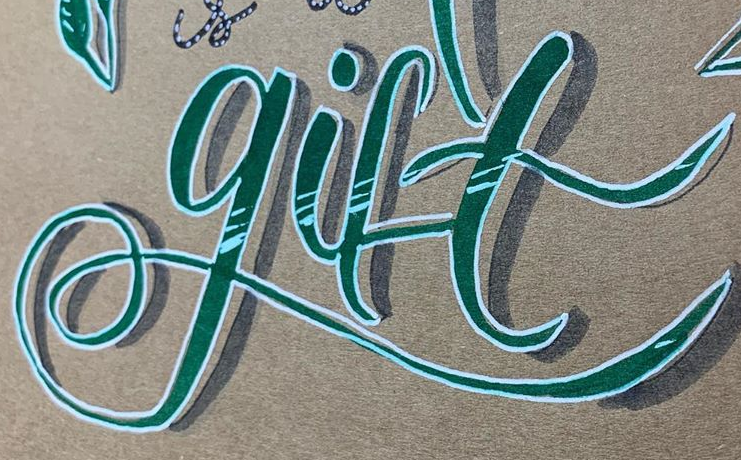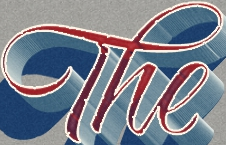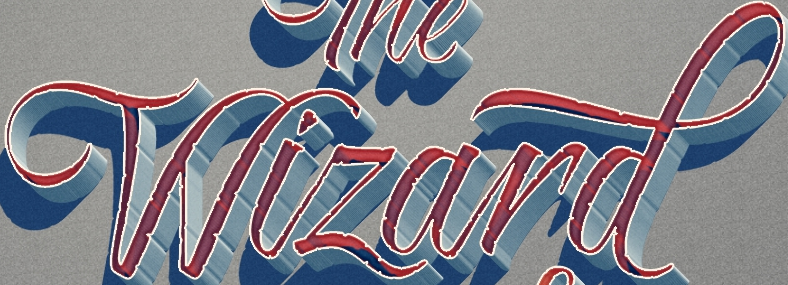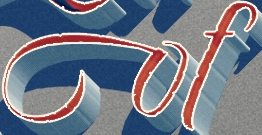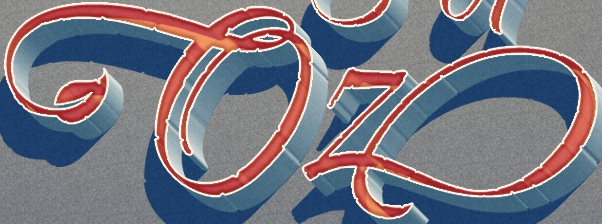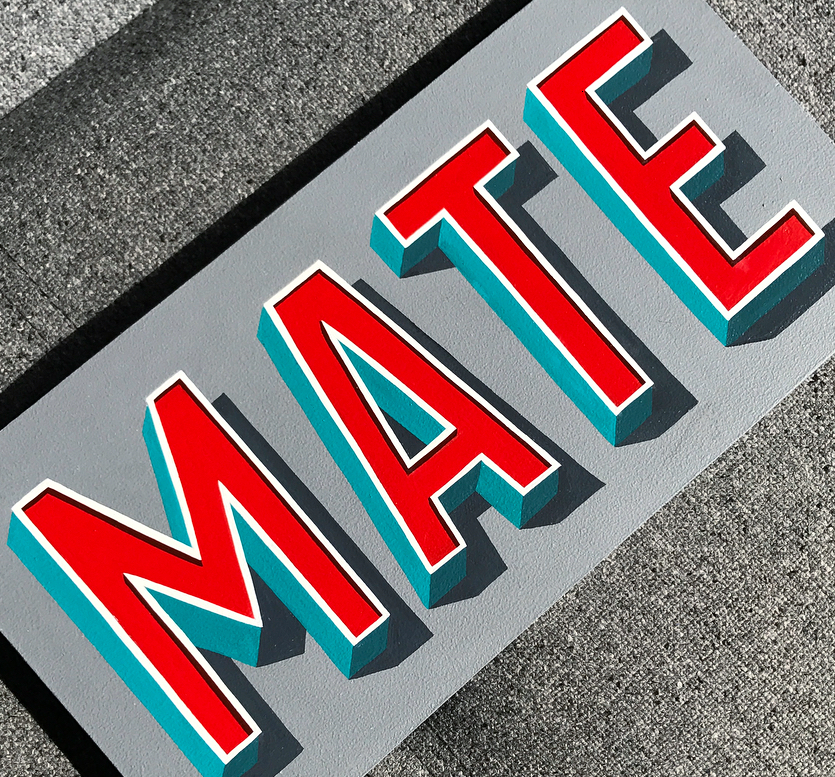What words can you see in these images in sequence, separated by a semicolon? gift; The; Wizard; of; Oz; MATE 